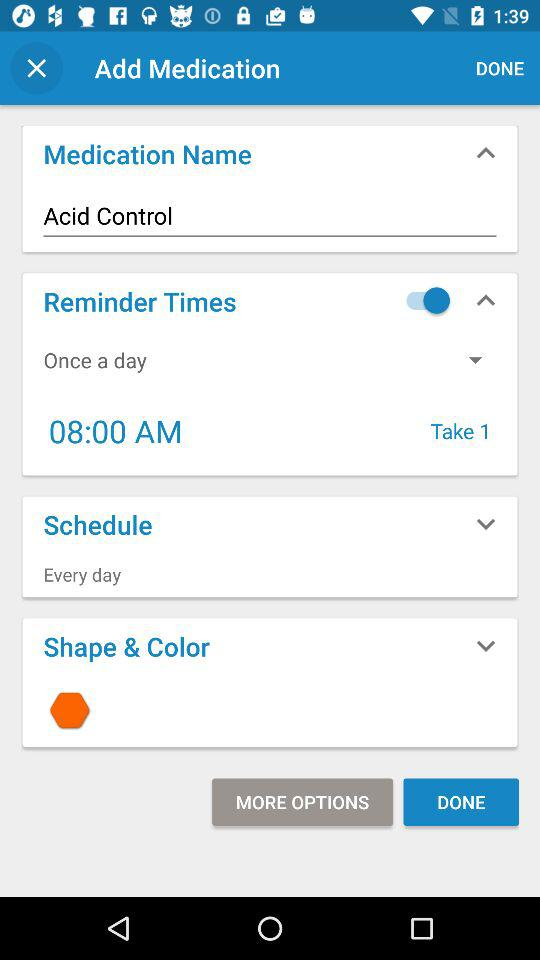At what time should medicine be taken? It should be taken at 8:00 AM. 